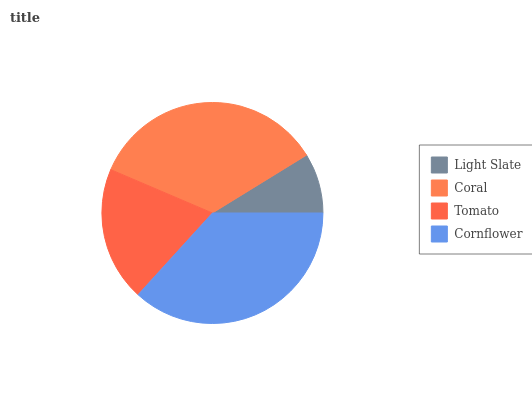Is Light Slate the minimum?
Answer yes or no. Yes. Is Cornflower the maximum?
Answer yes or no. Yes. Is Coral the minimum?
Answer yes or no. No. Is Coral the maximum?
Answer yes or no. No. Is Coral greater than Light Slate?
Answer yes or no. Yes. Is Light Slate less than Coral?
Answer yes or no. Yes. Is Light Slate greater than Coral?
Answer yes or no. No. Is Coral less than Light Slate?
Answer yes or no. No. Is Coral the high median?
Answer yes or no. Yes. Is Tomato the low median?
Answer yes or no. Yes. Is Cornflower the high median?
Answer yes or no. No. Is Light Slate the low median?
Answer yes or no. No. 